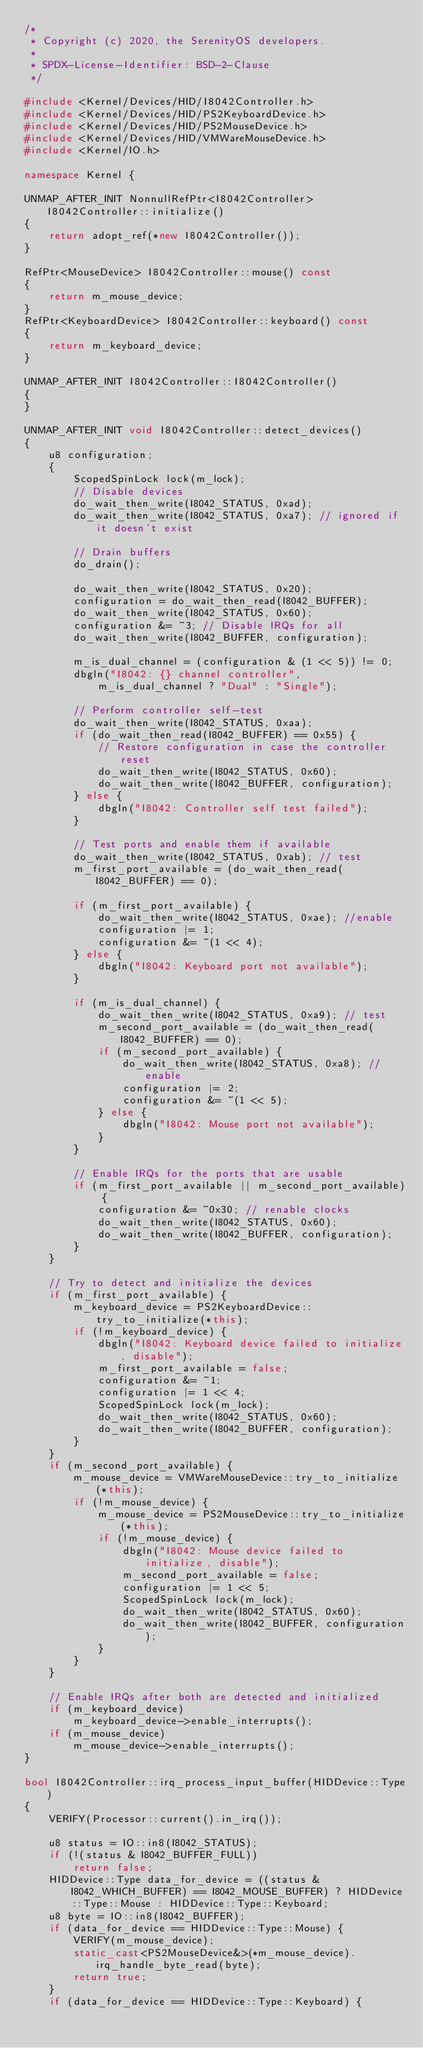<code> <loc_0><loc_0><loc_500><loc_500><_C++_>/*
 * Copyright (c) 2020, the SerenityOS developers.
 *
 * SPDX-License-Identifier: BSD-2-Clause
 */

#include <Kernel/Devices/HID/I8042Controller.h>
#include <Kernel/Devices/HID/PS2KeyboardDevice.h>
#include <Kernel/Devices/HID/PS2MouseDevice.h>
#include <Kernel/Devices/HID/VMWareMouseDevice.h>
#include <Kernel/IO.h>

namespace Kernel {

UNMAP_AFTER_INIT NonnullRefPtr<I8042Controller> I8042Controller::initialize()
{
    return adopt_ref(*new I8042Controller());
}

RefPtr<MouseDevice> I8042Controller::mouse() const
{
    return m_mouse_device;
}
RefPtr<KeyboardDevice> I8042Controller::keyboard() const
{
    return m_keyboard_device;
}

UNMAP_AFTER_INIT I8042Controller::I8042Controller()
{
}

UNMAP_AFTER_INIT void I8042Controller::detect_devices()
{
    u8 configuration;
    {
        ScopedSpinLock lock(m_lock);
        // Disable devices
        do_wait_then_write(I8042_STATUS, 0xad);
        do_wait_then_write(I8042_STATUS, 0xa7); // ignored if it doesn't exist

        // Drain buffers
        do_drain();

        do_wait_then_write(I8042_STATUS, 0x20);
        configuration = do_wait_then_read(I8042_BUFFER);
        do_wait_then_write(I8042_STATUS, 0x60);
        configuration &= ~3; // Disable IRQs for all
        do_wait_then_write(I8042_BUFFER, configuration);

        m_is_dual_channel = (configuration & (1 << 5)) != 0;
        dbgln("I8042: {} channel controller",
            m_is_dual_channel ? "Dual" : "Single");

        // Perform controller self-test
        do_wait_then_write(I8042_STATUS, 0xaa);
        if (do_wait_then_read(I8042_BUFFER) == 0x55) {
            // Restore configuration in case the controller reset
            do_wait_then_write(I8042_STATUS, 0x60);
            do_wait_then_write(I8042_BUFFER, configuration);
        } else {
            dbgln("I8042: Controller self test failed");
        }

        // Test ports and enable them if available
        do_wait_then_write(I8042_STATUS, 0xab); // test
        m_first_port_available = (do_wait_then_read(I8042_BUFFER) == 0);

        if (m_first_port_available) {
            do_wait_then_write(I8042_STATUS, 0xae); //enable
            configuration |= 1;
            configuration &= ~(1 << 4);
        } else {
            dbgln("I8042: Keyboard port not available");
        }

        if (m_is_dual_channel) {
            do_wait_then_write(I8042_STATUS, 0xa9); // test
            m_second_port_available = (do_wait_then_read(I8042_BUFFER) == 0);
            if (m_second_port_available) {
                do_wait_then_write(I8042_STATUS, 0xa8); // enable
                configuration |= 2;
                configuration &= ~(1 << 5);
            } else {
                dbgln("I8042: Mouse port not available");
            }
        }

        // Enable IRQs for the ports that are usable
        if (m_first_port_available || m_second_port_available) {
            configuration &= ~0x30; // renable clocks
            do_wait_then_write(I8042_STATUS, 0x60);
            do_wait_then_write(I8042_BUFFER, configuration);
        }
    }

    // Try to detect and initialize the devices
    if (m_first_port_available) {
        m_keyboard_device = PS2KeyboardDevice::try_to_initialize(*this);
        if (!m_keyboard_device) {
            dbgln("I8042: Keyboard device failed to initialize, disable");
            m_first_port_available = false;
            configuration &= ~1;
            configuration |= 1 << 4;
            ScopedSpinLock lock(m_lock);
            do_wait_then_write(I8042_STATUS, 0x60);
            do_wait_then_write(I8042_BUFFER, configuration);
        }
    }
    if (m_second_port_available) {
        m_mouse_device = VMWareMouseDevice::try_to_initialize(*this);
        if (!m_mouse_device) {
            m_mouse_device = PS2MouseDevice::try_to_initialize(*this);
            if (!m_mouse_device) {
                dbgln("I8042: Mouse device failed to initialize, disable");
                m_second_port_available = false;
                configuration |= 1 << 5;
                ScopedSpinLock lock(m_lock);
                do_wait_then_write(I8042_STATUS, 0x60);
                do_wait_then_write(I8042_BUFFER, configuration);
            }
        }
    }

    // Enable IRQs after both are detected and initialized
    if (m_keyboard_device)
        m_keyboard_device->enable_interrupts();
    if (m_mouse_device)
        m_mouse_device->enable_interrupts();
}

bool I8042Controller::irq_process_input_buffer(HIDDevice::Type)
{
    VERIFY(Processor::current().in_irq());

    u8 status = IO::in8(I8042_STATUS);
    if (!(status & I8042_BUFFER_FULL))
        return false;
    HIDDevice::Type data_for_device = ((status & I8042_WHICH_BUFFER) == I8042_MOUSE_BUFFER) ? HIDDevice::Type::Mouse : HIDDevice::Type::Keyboard;
    u8 byte = IO::in8(I8042_BUFFER);
    if (data_for_device == HIDDevice::Type::Mouse) {
        VERIFY(m_mouse_device);
        static_cast<PS2MouseDevice&>(*m_mouse_device).irq_handle_byte_read(byte);
        return true;
    }
    if (data_for_device == HIDDevice::Type::Keyboard) {</code> 